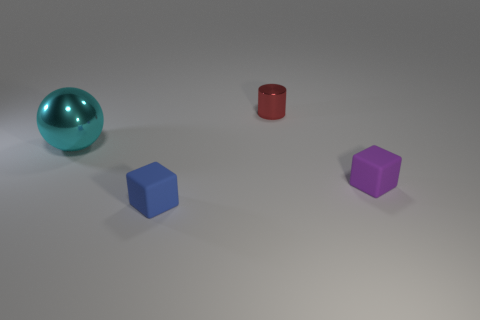Add 3 blue objects. How many objects exist? 7 Subtract all balls. How many objects are left? 3 Add 3 small purple matte cubes. How many small purple matte cubes exist? 4 Subtract 0 yellow cylinders. How many objects are left? 4 Subtract all tiny matte blocks. Subtract all metal cylinders. How many objects are left? 1 Add 2 blue matte things. How many blue matte things are left? 3 